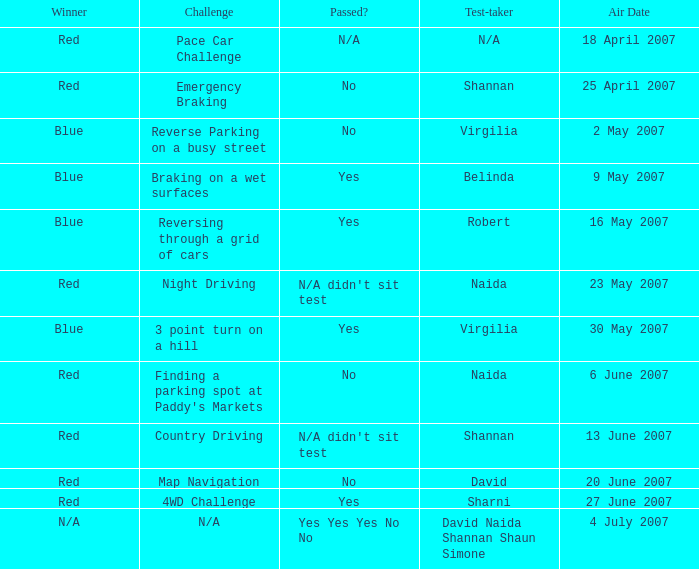What air date has a red winner and an emergency braking challenge? 25 April 2007. 